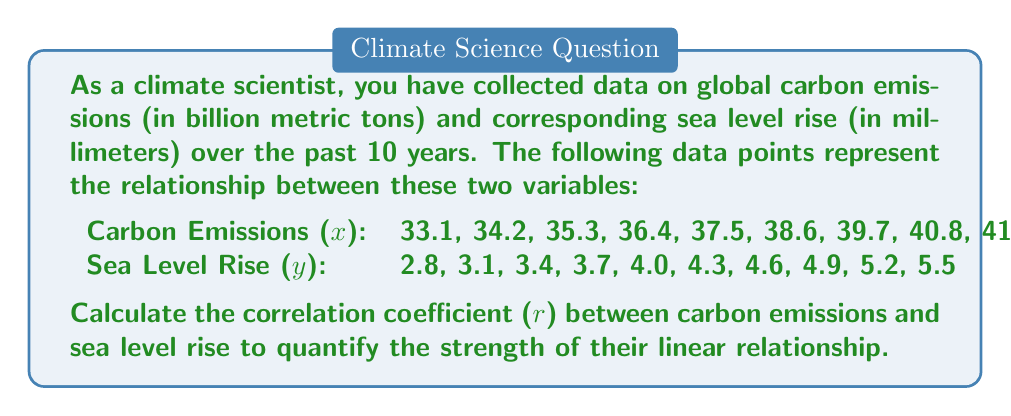Help me with this question. To calculate the correlation coefficient (r), we'll use the formula:

$$ r = \frac{n\sum xy - (\sum x)(\sum y)}{\sqrt{[n\sum x^2 - (\sum x)^2][n\sum y^2 - (\sum y)^2]}} $$

Where:
n = number of data points
x = carbon emissions
y = sea level rise

Step 1: Calculate the required sums:
n = 10
$\sum x = 380.5$
$\sum y = 41.5$
$\sum xy = 1623.75$
$\sum x^2 = 14678.55$
$\sum y^2 = 176.35$

Step 2: Calculate $(\sum x)^2$ and $(\sum y)^2$:
$(\sum x)^2 = 144780.25$
$(\sum y)^2 = 1722.25$

Step 3: Apply the formula:

$$ r = \frac{10(1623.75) - (380.5)(41.5)}{\sqrt{[10(14678.55) - 144780.25][10(176.35) - 1722.25]}} $$

$$ r = \frac{16237.5 - 15790.75}{\sqrt{(2005.25)(41.25)}} $$

$$ r = \frac{446.75}{\sqrt{82716.5625}} $$

$$ r = \frac{446.75}{287.6049} $$

$$ r \approx 0.9999 $$

Step 4: Interpret the result:
The correlation coefficient is approximately 0.9999, which indicates an extremely strong positive linear relationship between carbon emissions and sea level rise.
Answer: $r \approx 0.9999$ 